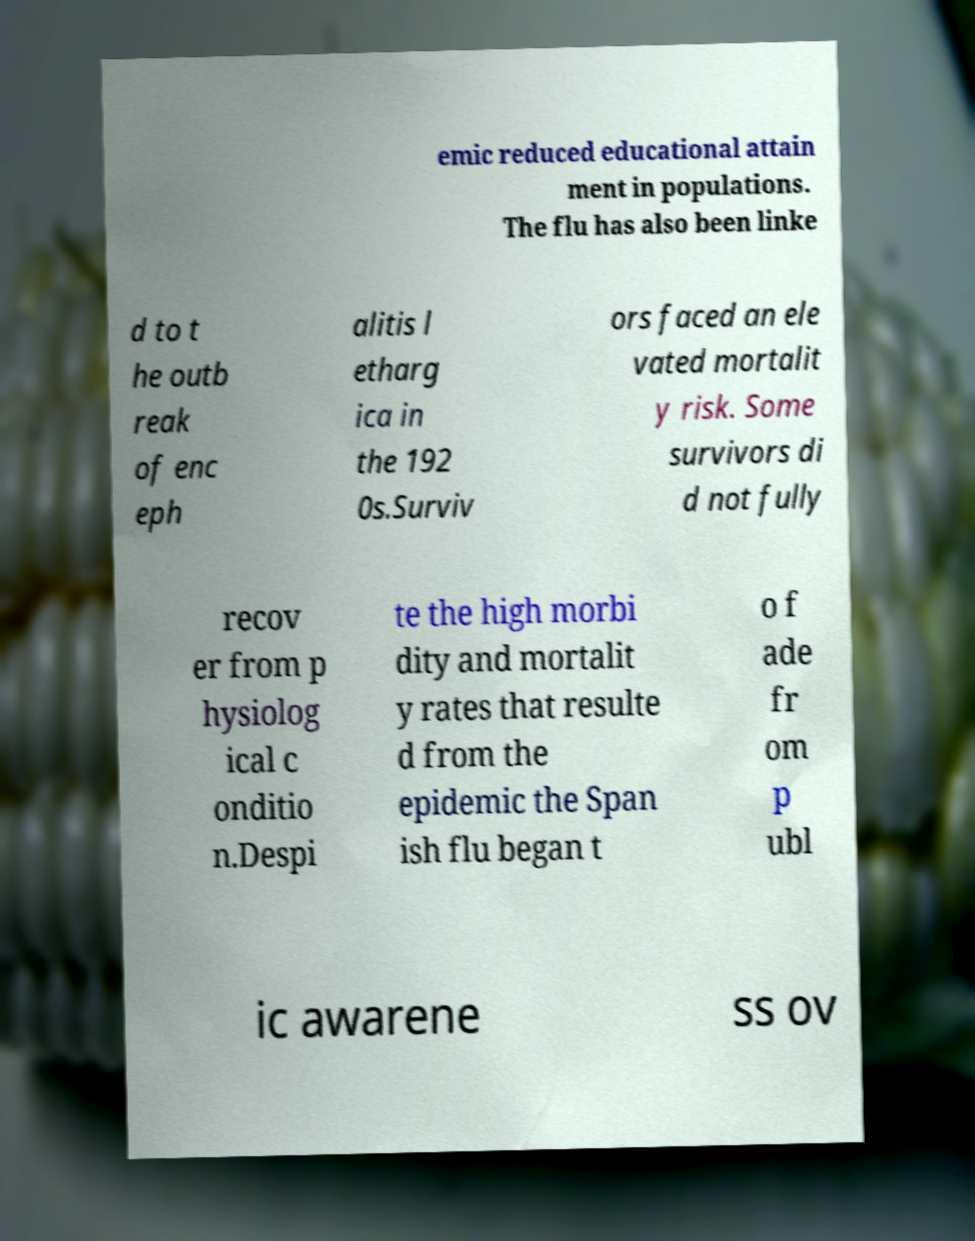There's text embedded in this image that I need extracted. Can you transcribe it verbatim? emic reduced educational attain ment in populations. The flu has also been linke d to t he outb reak of enc eph alitis l etharg ica in the 192 0s.Surviv ors faced an ele vated mortalit y risk. Some survivors di d not fully recov er from p hysiolog ical c onditio n.Despi te the high morbi dity and mortalit y rates that resulte d from the epidemic the Span ish flu began t o f ade fr om p ubl ic awarene ss ov 